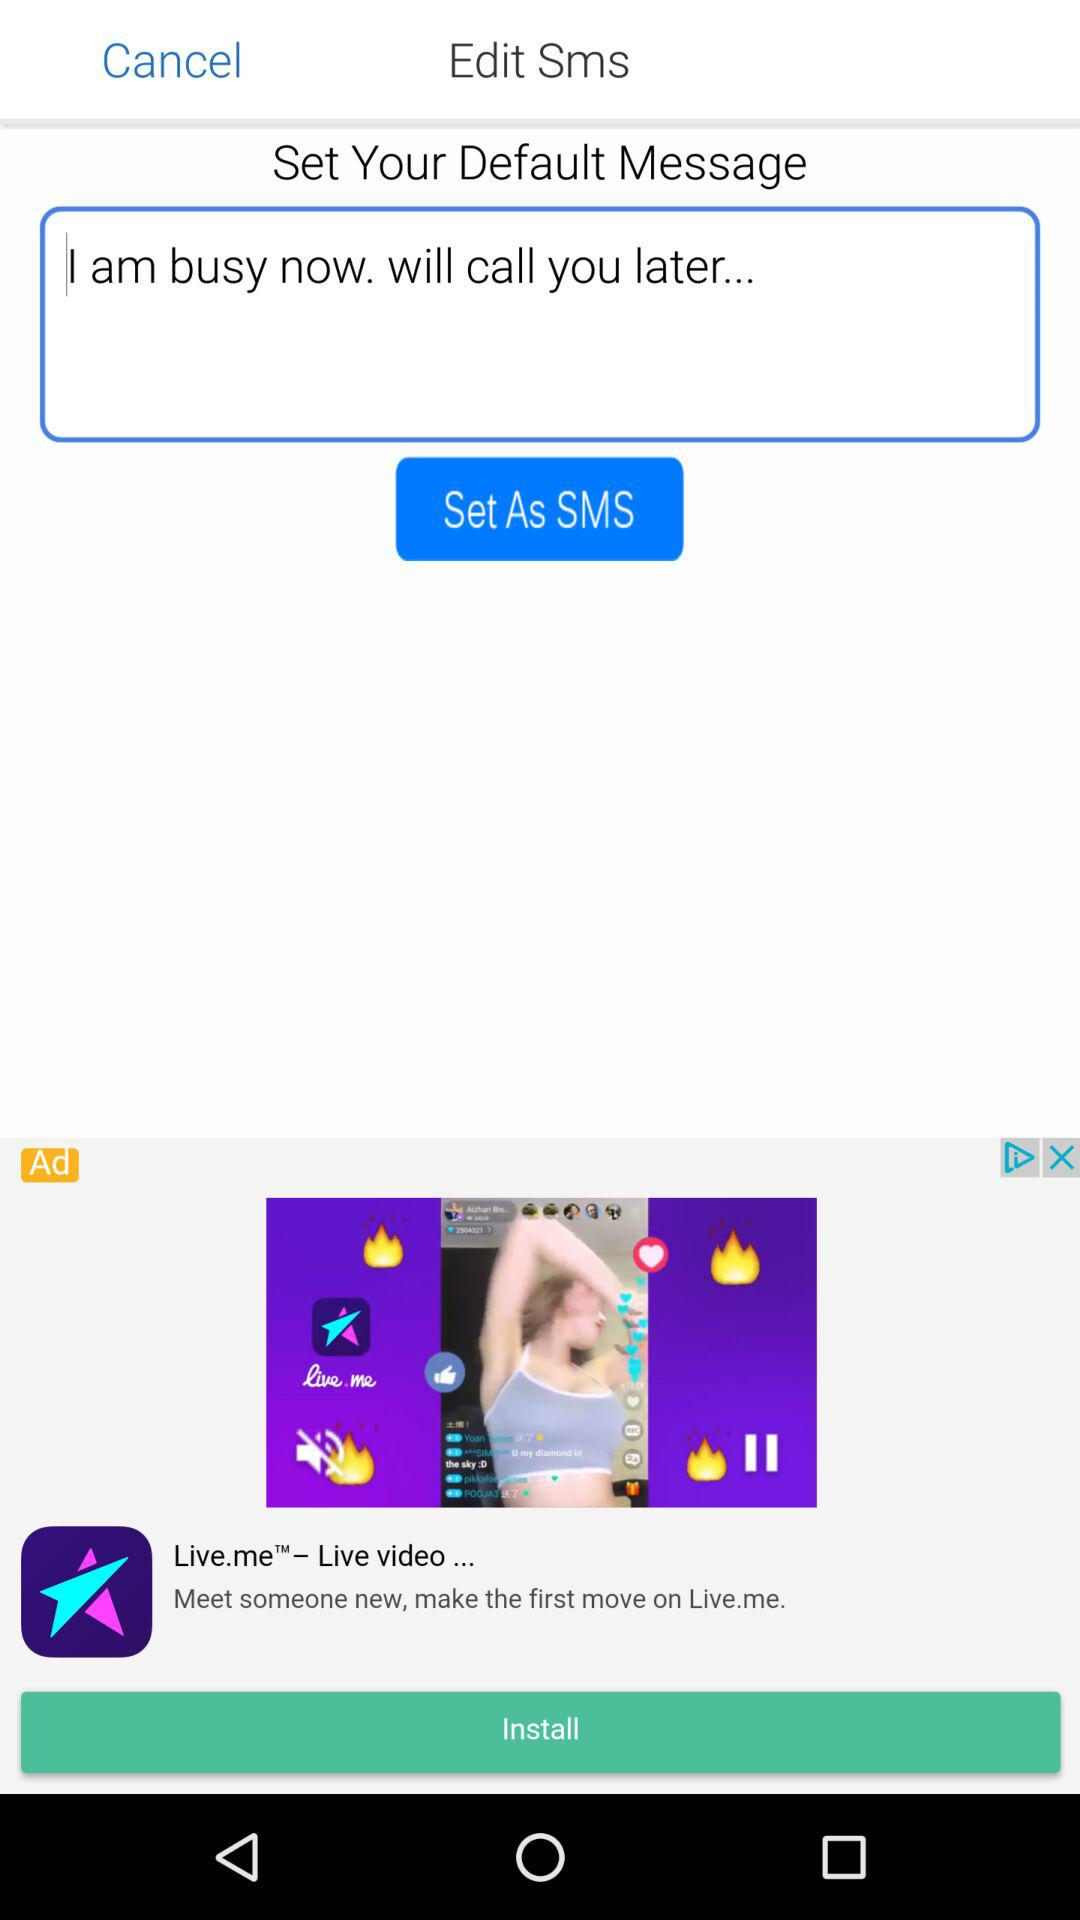What default message can be set as an SMS? The default message that can be set as an SMS is "I am busy now. will call you later...". 